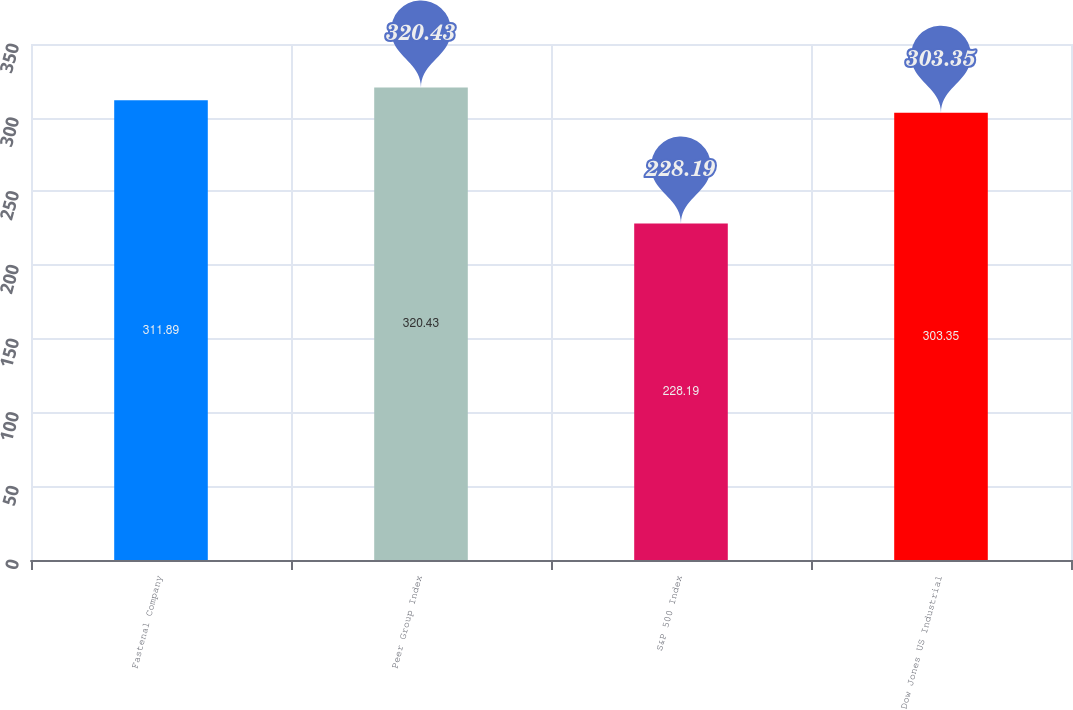<chart> <loc_0><loc_0><loc_500><loc_500><bar_chart><fcel>Fastenal Company<fcel>Peer Group Index<fcel>S&P 500 Index<fcel>Dow Jones US Industrial<nl><fcel>311.89<fcel>320.43<fcel>228.19<fcel>303.35<nl></chart> 